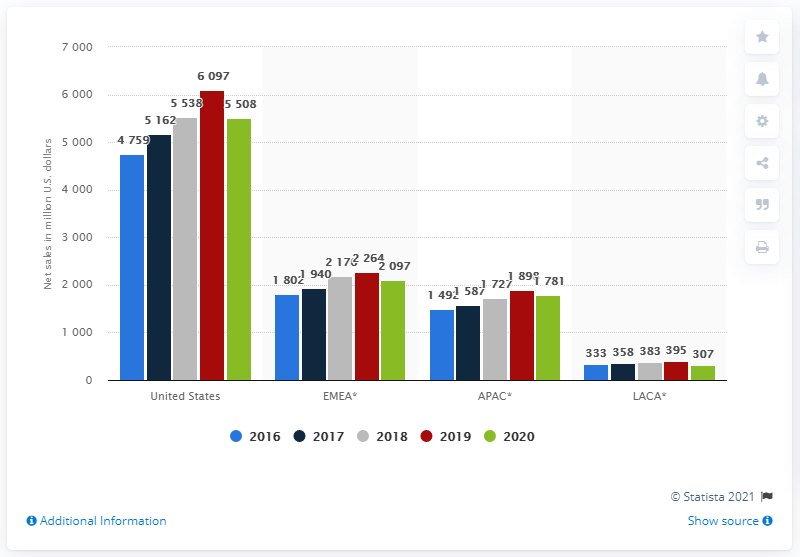Specify some key components in this picture. The United States had the largest humbers for the green bar. Boston Scientific generated approximately $55,380,000 in revenue in the United States in 2020. In the year 2018, the United States of America (USA) and the European, Middle Eastern and African (EMEA) regions had differences in various aspects. 